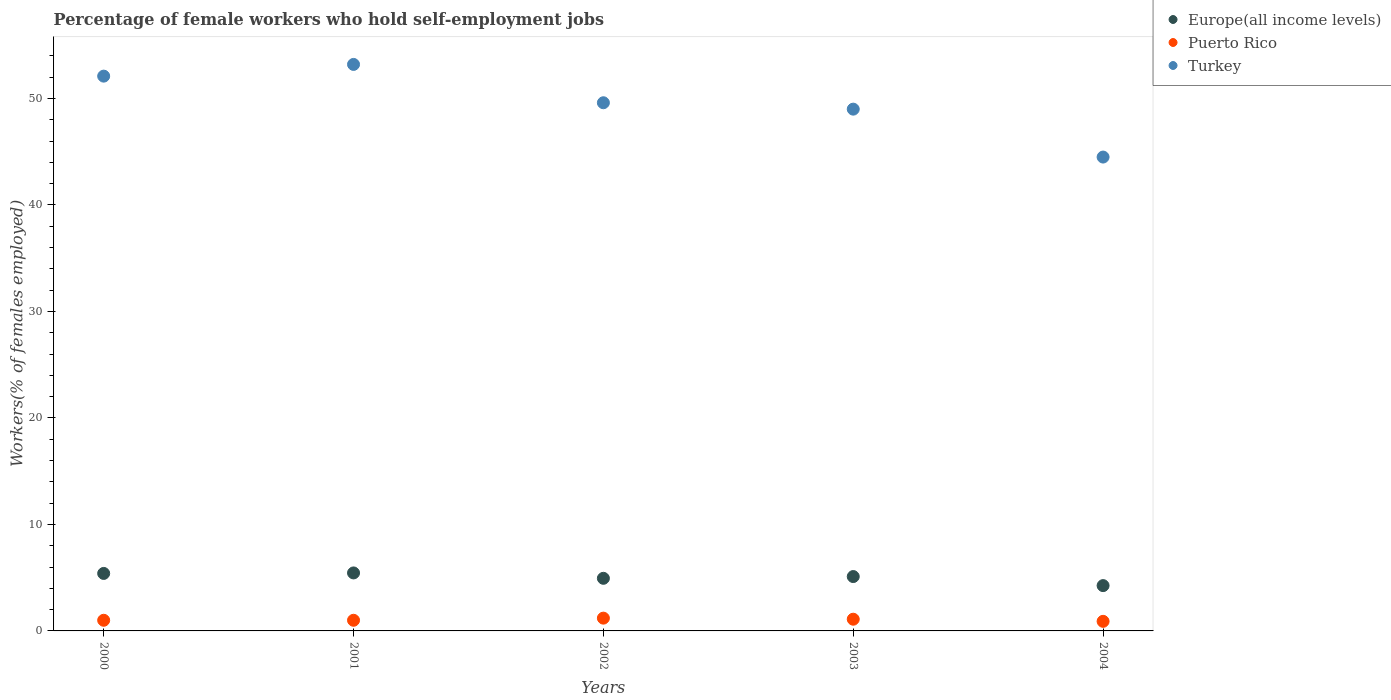Is the number of dotlines equal to the number of legend labels?
Offer a terse response. Yes. What is the percentage of self-employed female workers in Europe(all income levels) in 2002?
Make the answer very short. 4.94. Across all years, what is the maximum percentage of self-employed female workers in Turkey?
Your response must be concise. 53.2. Across all years, what is the minimum percentage of self-employed female workers in Europe(all income levels)?
Your answer should be compact. 4.25. In which year was the percentage of self-employed female workers in Puerto Rico maximum?
Your response must be concise. 2002. What is the total percentage of self-employed female workers in Puerto Rico in the graph?
Provide a short and direct response. 5.2. What is the difference between the percentage of self-employed female workers in Europe(all income levels) in 2002 and the percentage of self-employed female workers in Puerto Rico in 2000?
Offer a very short reply. 3.94. What is the average percentage of self-employed female workers in Turkey per year?
Ensure brevity in your answer.  49.68. In the year 2004, what is the difference between the percentage of self-employed female workers in Puerto Rico and percentage of self-employed female workers in Europe(all income levels)?
Give a very brief answer. -3.35. What is the ratio of the percentage of self-employed female workers in Puerto Rico in 2001 to that in 2004?
Provide a succinct answer. 1.11. What is the difference between the highest and the second highest percentage of self-employed female workers in Turkey?
Provide a short and direct response. 1.1. What is the difference between the highest and the lowest percentage of self-employed female workers in Europe(all income levels)?
Your answer should be very brief. 1.19. In how many years, is the percentage of self-employed female workers in Turkey greater than the average percentage of self-employed female workers in Turkey taken over all years?
Make the answer very short. 2. What is the difference between two consecutive major ticks on the Y-axis?
Your response must be concise. 10. Are the values on the major ticks of Y-axis written in scientific E-notation?
Give a very brief answer. No. Does the graph contain any zero values?
Provide a succinct answer. No. Where does the legend appear in the graph?
Ensure brevity in your answer.  Top right. How are the legend labels stacked?
Your answer should be very brief. Vertical. What is the title of the graph?
Your answer should be compact. Percentage of female workers who hold self-employment jobs. Does "Australia" appear as one of the legend labels in the graph?
Your answer should be very brief. No. What is the label or title of the X-axis?
Offer a very short reply. Years. What is the label or title of the Y-axis?
Offer a very short reply. Workers(% of females employed). What is the Workers(% of females employed) in Europe(all income levels) in 2000?
Give a very brief answer. 5.4. What is the Workers(% of females employed) of Turkey in 2000?
Provide a short and direct response. 52.1. What is the Workers(% of females employed) in Europe(all income levels) in 2001?
Your response must be concise. 5.45. What is the Workers(% of females employed) of Turkey in 2001?
Offer a very short reply. 53.2. What is the Workers(% of females employed) in Europe(all income levels) in 2002?
Offer a terse response. 4.94. What is the Workers(% of females employed) in Puerto Rico in 2002?
Keep it short and to the point. 1.2. What is the Workers(% of females employed) in Turkey in 2002?
Give a very brief answer. 49.6. What is the Workers(% of females employed) in Europe(all income levels) in 2003?
Make the answer very short. 5.11. What is the Workers(% of females employed) of Puerto Rico in 2003?
Your answer should be very brief. 1.1. What is the Workers(% of females employed) in Europe(all income levels) in 2004?
Make the answer very short. 4.25. What is the Workers(% of females employed) in Puerto Rico in 2004?
Your answer should be very brief. 0.9. What is the Workers(% of females employed) of Turkey in 2004?
Give a very brief answer. 44.5. Across all years, what is the maximum Workers(% of females employed) in Europe(all income levels)?
Your answer should be very brief. 5.45. Across all years, what is the maximum Workers(% of females employed) of Puerto Rico?
Make the answer very short. 1.2. Across all years, what is the maximum Workers(% of females employed) in Turkey?
Your answer should be compact. 53.2. Across all years, what is the minimum Workers(% of females employed) in Europe(all income levels)?
Give a very brief answer. 4.25. Across all years, what is the minimum Workers(% of females employed) in Puerto Rico?
Provide a succinct answer. 0.9. Across all years, what is the minimum Workers(% of females employed) in Turkey?
Your answer should be compact. 44.5. What is the total Workers(% of females employed) of Europe(all income levels) in the graph?
Make the answer very short. 25.15. What is the total Workers(% of females employed) in Turkey in the graph?
Provide a succinct answer. 248.4. What is the difference between the Workers(% of females employed) in Europe(all income levels) in 2000 and that in 2001?
Your response must be concise. -0.05. What is the difference between the Workers(% of females employed) of Turkey in 2000 and that in 2001?
Your answer should be very brief. -1.1. What is the difference between the Workers(% of females employed) in Europe(all income levels) in 2000 and that in 2002?
Offer a terse response. 0.46. What is the difference between the Workers(% of females employed) in Europe(all income levels) in 2000 and that in 2003?
Make the answer very short. 0.29. What is the difference between the Workers(% of females employed) of Turkey in 2000 and that in 2003?
Your answer should be very brief. 3.1. What is the difference between the Workers(% of females employed) of Europe(all income levels) in 2000 and that in 2004?
Keep it short and to the point. 1.14. What is the difference between the Workers(% of females employed) of Puerto Rico in 2000 and that in 2004?
Provide a short and direct response. 0.1. What is the difference between the Workers(% of females employed) in Europe(all income levels) in 2001 and that in 2002?
Make the answer very short. 0.5. What is the difference between the Workers(% of females employed) of Puerto Rico in 2001 and that in 2002?
Offer a terse response. -0.2. What is the difference between the Workers(% of females employed) in Europe(all income levels) in 2001 and that in 2003?
Make the answer very short. 0.34. What is the difference between the Workers(% of females employed) in Puerto Rico in 2001 and that in 2003?
Ensure brevity in your answer.  -0.1. What is the difference between the Workers(% of females employed) in Turkey in 2001 and that in 2003?
Your answer should be very brief. 4.2. What is the difference between the Workers(% of females employed) in Europe(all income levels) in 2001 and that in 2004?
Ensure brevity in your answer.  1.19. What is the difference between the Workers(% of females employed) of Turkey in 2001 and that in 2004?
Give a very brief answer. 8.7. What is the difference between the Workers(% of females employed) of Europe(all income levels) in 2002 and that in 2003?
Provide a succinct answer. -0.16. What is the difference between the Workers(% of females employed) in Puerto Rico in 2002 and that in 2003?
Make the answer very short. 0.1. What is the difference between the Workers(% of females employed) in Turkey in 2002 and that in 2003?
Make the answer very short. 0.6. What is the difference between the Workers(% of females employed) in Europe(all income levels) in 2002 and that in 2004?
Your answer should be compact. 0.69. What is the difference between the Workers(% of females employed) in Europe(all income levels) in 2003 and that in 2004?
Give a very brief answer. 0.85. What is the difference between the Workers(% of females employed) of Puerto Rico in 2003 and that in 2004?
Your answer should be very brief. 0.2. What is the difference between the Workers(% of females employed) of Europe(all income levels) in 2000 and the Workers(% of females employed) of Puerto Rico in 2001?
Your response must be concise. 4.4. What is the difference between the Workers(% of females employed) in Europe(all income levels) in 2000 and the Workers(% of females employed) in Turkey in 2001?
Your answer should be compact. -47.8. What is the difference between the Workers(% of females employed) in Puerto Rico in 2000 and the Workers(% of females employed) in Turkey in 2001?
Offer a very short reply. -52.2. What is the difference between the Workers(% of females employed) in Europe(all income levels) in 2000 and the Workers(% of females employed) in Puerto Rico in 2002?
Your answer should be compact. 4.2. What is the difference between the Workers(% of females employed) of Europe(all income levels) in 2000 and the Workers(% of females employed) of Turkey in 2002?
Your answer should be compact. -44.2. What is the difference between the Workers(% of females employed) in Puerto Rico in 2000 and the Workers(% of females employed) in Turkey in 2002?
Give a very brief answer. -48.6. What is the difference between the Workers(% of females employed) of Europe(all income levels) in 2000 and the Workers(% of females employed) of Puerto Rico in 2003?
Provide a short and direct response. 4.3. What is the difference between the Workers(% of females employed) of Europe(all income levels) in 2000 and the Workers(% of females employed) of Turkey in 2003?
Provide a succinct answer. -43.6. What is the difference between the Workers(% of females employed) in Puerto Rico in 2000 and the Workers(% of females employed) in Turkey in 2003?
Your answer should be very brief. -48. What is the difference between the Workers(% of females employed) of Europe(all income levels) in 2000 and the Workers(% of females employed) of Puerto Rico in 2004?
Your response must be concise. 4.5. What is the difference between the Workers(% of females employed) in Europe(all income levels) in 2000 and the Workers(% of females employed) in Turkey in 2004?
Offer a terse response. -39.1. What is the difference between the Workers(% of females employed) in Puerto Rico in 2000 and the Workers(% of females employed) in Turkey in 2004?
Provide a succinct answer. -43.5. What is the difference between the Workers(% of females employed) in Europe(all income levels) in 2001 and the Workers(% of females employed) in Puerto Rico in 2002?
Provide a short and direct response. 4.25. What is the difference between the Workers(% of females employed) in Europe(all income levels) in 2001 and the Workers(% of females employed) in Turkey in 2002?
Keep it short and to the point. -44.15. What is the difference between the Workers(% of females employed) in Puerto Rico in 2001 and the Workers(% of females employed) in Turkey in 2002?
Provide a short and direct response. -48.6. What is the difference between the Workers(% of females employed) in Europe(all income levels) in 2001 and the Workers(% of females employed) in Puerto Rico in 2003?
Offer a very short reply. 4.35. What is the difference between the Workers(% of females employed) in Europe(all income levels) in 2001 and the Workers(% of females employed) in Turkey in 2003?
Provide a short and direct response. -43.55. What is the difference between the Workers(% of females employed) of Puerto Rico in 2001 and the Workers(% of females employed) of Turkey in 2003?
Offer a very short reply. -48. What is the difference between the Workers(% of females employed) of Europe(all income levels) in 2001 and the Workers(% of females employed) of Puerto Rico in 2004?
Your answer should be compact. 4.55. What is the difference between the Workers(% of females employed) in Europe(all income levels) in 2001 and the Workers(% of females employed) in Turkey in 2004?
Offer a very short reply. -39.05. What is the difference between the Workers(% of females employed) of Puerto Rico in 2001 and the Workers(% of females employed) of Turkey in 2004?
Offer a terse response. -43.5. What is the difference between the Workers(% of females employed) in Europe(all income levels) in 2002 and the Workers(% of females employed) in Puerto Rico in 2003?
Provide a short and direct response. 3.84. What is the difference between the Workers(% of females employed) in Europe(all income levels) in 2002 and the Workers(% of females employed) in Turkey in 2003?
Keep it short and to the point. -44.06. What is the difference between the Workers(% of females employed) of Puerto Rico in 2002 and the Workers(% of females employed) of Turkey in 2003?
Your answer should be very brief. -47.8. What is the difference between the Workers(% of females employed) in Europe(all income levels) in 2002 and the Workers(% of females employed) in Puerto Rico in 2004?
Ensure brevity in your answer.  4.04. What is the difference between the Workers(% of females employed) of Europe(all income levels) in 2002 and the Workers(% of females employed) of Turkey in 2004?
Your answer should be very brief. -39.56. What is the difference between the Workers(% of females employed) in Puerto Rico in 2002 and the Workers(% of females employed) in Turkey in 2004?
Ensure brevity in your answer.  -43.3. What is the difference between the Workers(% of females employed) of Europe(all income levels) in 2003 and the Workers(% of females employed) of Puerto Rico in 2004?
Your answer should be very brief. 4.21. What is the difference between the Workers(% of females employed) of Europe(all income levels) in 2003 and the Workers(% of females employed) of Turkey in 2004?
Provide a short and direct response. -39.39. What is the difference between the Workers(% of females employed) in Puerto Rico in 2003 and the Workers(% of females employed) in Turkey in 2004?
Offer a very short reply. -43.4. What is the average Workers(% of females employed) in Europe(all income levels) per year?
Your response must be concise. 5.03. What is the average Workers(% of females employed) in Puerto Rico per year?
Keep it short and to the point. 1.04. What is the average Workers(% of females employed) in Turkey per year?
Ensure brevity in your answer.  49.68. In the year 2000, what is the difference between the Workers(% of females employed) in Europe(all income levels) and Workers(% of females employed) in Puerto Rico?
Make the answer very short. 4.4. In the year 2000, what is the difference between the Workers(% of females employed) of Europe(all income levels) and Workers(% of females employed) of Turkey?
Provide a succinct answer. -46.7. In the year 2000, what is the difference between the Workers(% of females employed) of Puerto Rico and Workers(% of females employed) of Turkey?
Offer a very short reply. -51.1. In the year 2001, what is the difference between the Workers(% of females employed) in Europe(all income levels) and Workers(% of females employed) in Puerto Rico?
Your response must be concise. 4.45. In the year 2001, what is the difference between the Workers(% of females employed) in Europe(all income levels) and Workers(% of females employed) in Turkey?
Ensure brevity in your answer.  -47.75. In the year 2001, what is the difference between the Workers(% of females employed) in Puerto Rico and Workers(% of females employed) in Turkey?
Provide a short and direct response. -52.2. In the year 2002, what is the difference between the Workers(% of females employed) of Europe(all income levels) and Workers(% of females employed) of Puerto Rico?
Provide a short and direct response. 3.74. In the year 2002, what is the difference between the Workers(% of females employed) in Europe(all income levels) and Workers(% of females employed) in Turkey?
Make the answer very short. -44.66. In the year 2002, what is the difference between the Workers(% of females employed) in Puerto Rico and Workers(% of females employed) in Turkey?
Your answer should be compact. -48.4. In the year 2003, what is the difference between the Workers(% of females employed) of Europe(all income levels) and Workers(% of females employed) of Puerto Rico?
Your answer should be very brief. 4.01. In the year 2003, what is the difference between the Workers(% of females employed) in Europe(all income levels) and Workers(% of females employed) in Turkey?
Your response must be concise. -43.89. In the year 2003, what is the difference between the Workers(% of females employed) of Puerto Rico and Workers(% of females employed) of Turkey?
Give a very brief answer. -47.9. In the year 2004, what is the difference between the Workers(% of females employed) of Europe(all income levels) and Workers(% of females employed) of Puerto Rico?
Offer a terse response. 3.35. In the year 2004, what is the difference between the Workers(% of females employed) in Europe(all income levels) and Workers(% of females employed) in Turkey?
Offer a very short reply. -40.25. In the year 2004, what is the difference between the Workers(% of females employed) of Puerto Rico and Workers(% of females employed) of Turkey?
Offer a very short reply. -43.6. What is the ratio of the Workers(% of females employed) in Puerto Rico in 2000 to that in 2001?
Give a very brief answer. 1. What is the ratio of the Workers(% of females employed) in Turkey in 2000 to that in 2001?
Keep it short and to the point. 0.98. What is the ratio of the Workers(% of females employed) in Europe(all income levels) in 2000 to that in 2002?
Your answer should be very brief. 1.09. What is the ratio of the Workers(% of females employed) in Puerto Rico in 2000 to that in 2002?
Ensure brevity in your answer.  0.83. What is the ratio of the Workers(% of females employed) in Turkey in 2000 to that in 2002?
Ensure brevity in your answer.  1.05. What is the ratio of the Workers(% of females employed) of Europe(all income levels) in 2000 to that in 2003?
Offer a very short reply. 1.06. What is the ratio of the Workers(% of females employed) of Turkey in 2000 to that in 2003?
Your response must be concise. 1.06. What is the ratio of the Workers(% of females employed) of Europe(all income levels) in 2000 to that in 2004?
Offer a terse response. 1.27. What is the ratio of the Workers(% of females employed) of Turkey in 2000 to that in 2004?
Offer a terse response. 1.17. What is the ratio of the Workers(% of females employed) of Europe(all income levels) in 2001 to that in 2002?
Your answer should be compact. 1.1. What is the ratio of the Workers(% of females employed) of Turkey in 2001 to that in 2002?
Your answer should be compact. 1.07. What is the ratio of the Workers(% of females employed) of Europe(all income levels) in 2001 to that in 2003?
Your answer should be very brief. 1.07. What is the ratio of the Workers(% of females employed) in Puerto Rico in 2001 to that in 2003?
Give a very brief answer. 0.91. What is the ratio of the Workers(% of females employed) in Turkey in 2001 to that in 2003?
Offer a terse response. 1.09. What is the ratio of the Workers(% of females employed) of Europe(all income levels) in 2001 to that in 2004?
Your answer should be very brief. 1.28. What is the ratio of the Workers(% of females employed) of Turkey in 2001 to that in 2004?
Offer a terse response. 1.2. What is the ratio of the Workers(% of females employed) of Europe(all income levels) in 2002 to that in 2003?
Your answer should be very brief. 0.97. What is the ratio of the Workers(% of females employed) in Turkey in 2002 to that in 2003?
Make the answer very short. 1.01. What is the ratio of the Workers(% of females employed) of Europe(all income levels) in 2002 to that in 2004?
Your answer should be very brief. 1.16. What is the ratio of the Workers(% of females employed) of Turkey in 2002 to that in 2004?
Keep it short and to the point. 1.11. What is the ratio of the Workers(% of females employed) in Europe(all income levels) in 2003 to that in 2004?
Provide a short and direct response. 1.2. What is the ratio of the Workers(% of females employed) in Puerto Rico in 2003 to that in 2004?
Provide a succinct answer. 1.22. What is the ratio of the Workers(% of females employed) of Turkey in 2003 to that in 2004?
Offer a very short reply. 1.1. What is the difference between the highest and the second highest Workers(% of females employed) in Europe(all income levels)?
Keep it short and to the point. 0.05. What is the difference between the highest and the second highest Workers(% of females employed) of Turkey?
Your response must be concise. 1.1. What is the difference between the highest and the lowest Workers(% of females employed) in Europe(all income levels)?
Keep it short and to the point. 1.19. What is the difference between the highest and the lowest Workers(% of females employed) of Puerto Rico?
Ensure brevity in your answer.  0.3. What is the difference between the highest and the lowest Workers(% of females employed) of Turkey?
Keep it short and to the point. 8.7. 